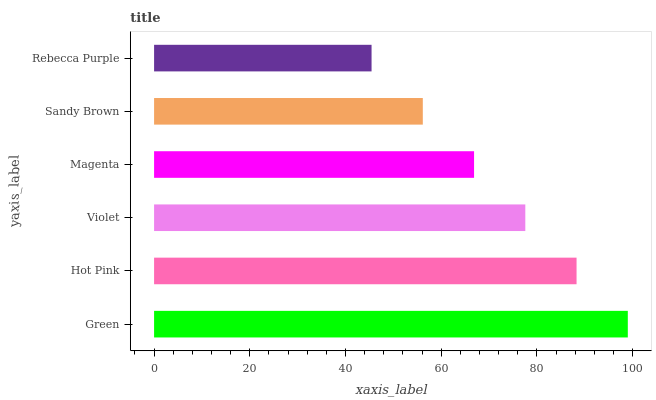Is Rebecca Purple the minimum?
Answer yes or no. Yes. Is Green the maximum?
Answer yes or no. Yes. Is Hot Pink the minimum?
Answer yes or no. No. Is Hot Pink the maximum?
Answer yes or no. No. Is Green greater than Hot Pink?
Answer yes or no. Yes. Is Hot Pink less than Green?
Answer yes or no. Yes. Is Hot Pink greater than Green?
Answer yes or no. No. Is Green less than Hot Pink?
Answer yes or no. No. Is Violet the high median?
Answer yes or no. Yes. Is Magenta the low median?
Answer yes or no. Yes. Is Magenta the high median?
Answer yes or no. No. Is Hot Pink the low median?
Answer yes or no. No. 